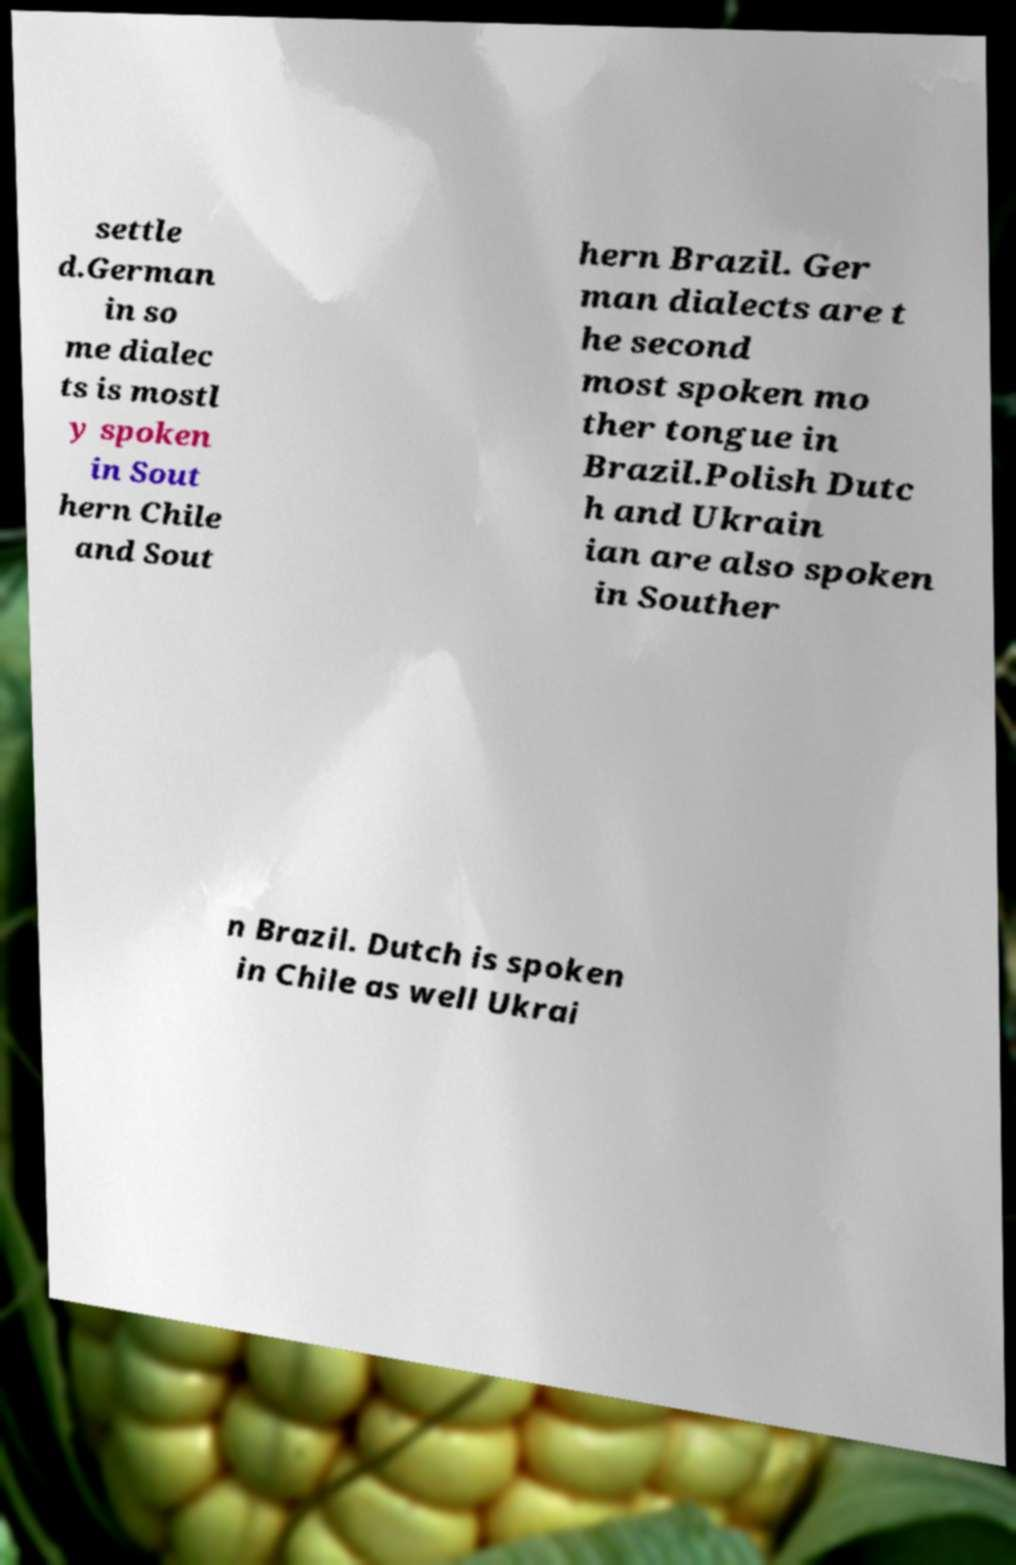Please identify and transcribe the text found in this image. settle d.German in so me dialec ts is mostl y spoken in Sout hern Chile and Sout hern Brazil. Ger man dialects are t he second most spoken mo ther tongue in Brazil.Polish Dutc h and Ukrain ian are also spoken in Souther n Brazil. Dutch is spoken in Chile as well Ukrai 